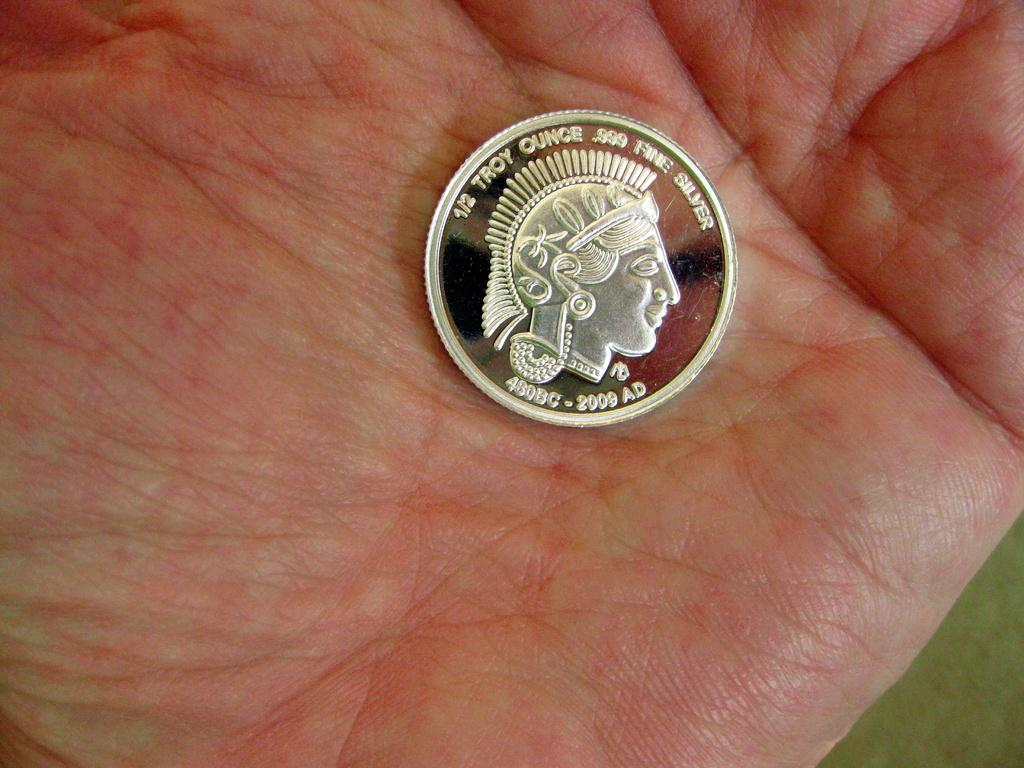What is the main object in the image? There is a currency coin in the image. What is the color of the coin? The coin is silver in color. Where is the coin located? The coin is on a human hand. Can you describe the hand in the image? The hand is red and cream in color. What type of pot is visible on the hand in the image? There is no pot visible on the hand in the image; it only features a currency coin. Can you tell me the address of the house in the image? There is no house present in the image, so it is not possible to provide an address. 